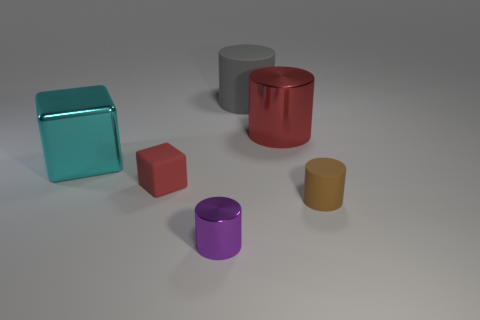Subtract all gray rubber cylinders. How many cylinders are left? 3 Subtract all gray cylinders. How many cylinders are left? 3 Subtract 1 cylinders. How many cylinders are left? 3 Add 1 small cylinders. How many objects exist? 7 Subtract all yellow cylinders. Subtract all yellow spheres. How many cylinders are left? 4 Subtract all cylinders. How many objects are left? 2 Add 5 green matte objects. How many green matte objects exist? 5 Subtract 1 gray cylinders. How many objects are left? 5 Subtract all small cylinders. Subtract all tiny gray cylinders. How many objects are left? 4 Add 6 tiny red matte cubes. How many tiny red matte cubes are left? 7 